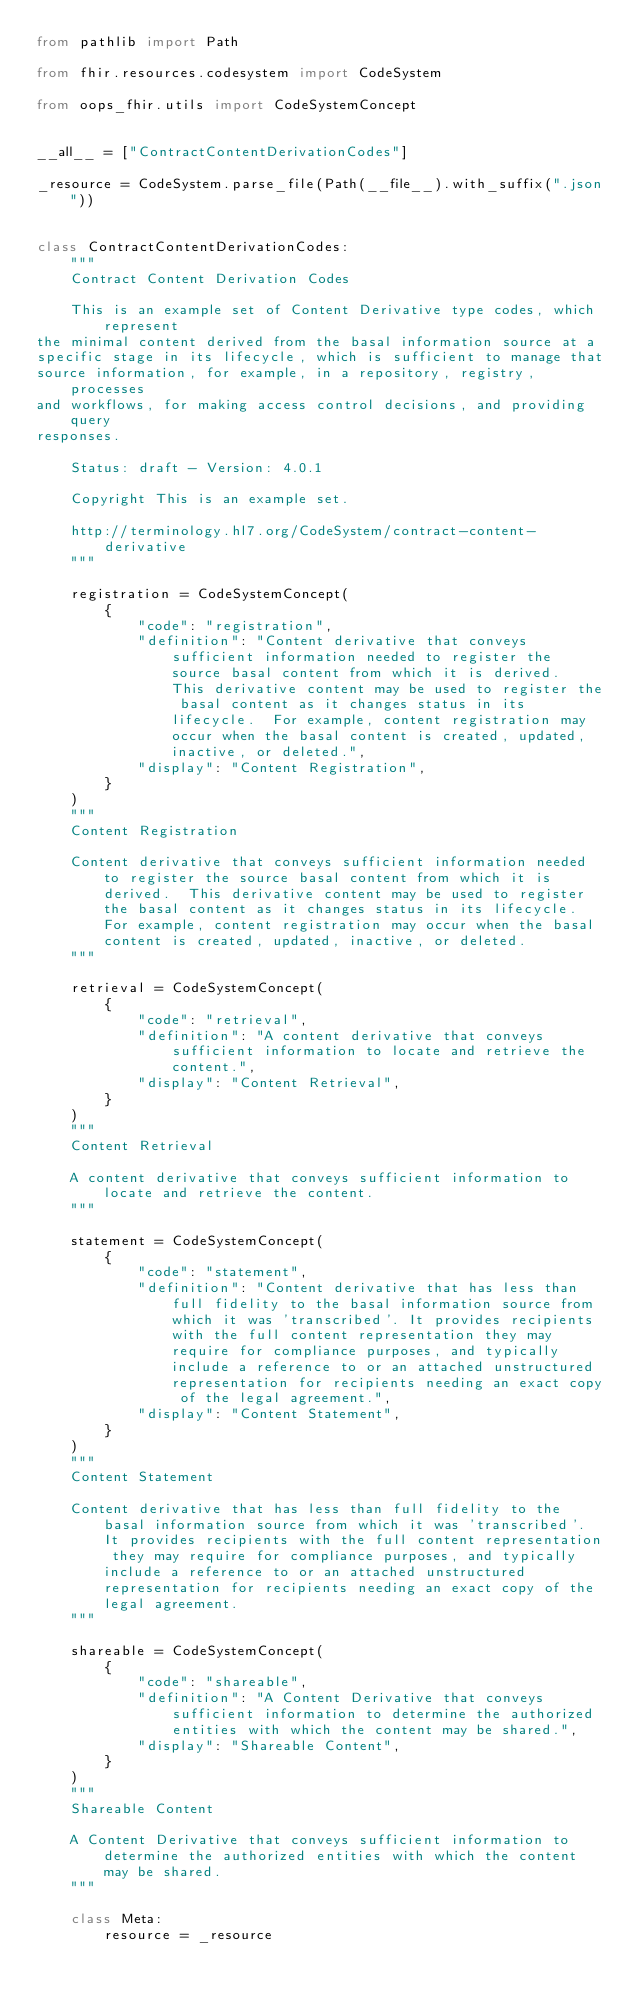Convert code to text. <code><loc_0><loc_0><loc_500><loc_500><_Python_>from pathlib import Path

from fhir.resources.codesystem import CodeSystem

from oops_fhir.utils import CodeSystemConcept


__all__ = ["ContractContentDerivationCodes"]

_resource = CodeSystem.parse_file(Path(__file__).with_suffix(".json"))


class ContractContentDerivationCodes:
    """
    Contract Content Derivation Codes

    This is an example set of Content Derivative type codes, which represent
the minimal content derived from the basal information source at a
specific stage in its lifecycle, which is sufficient to manage that
source information, for example, in a repository, registry, processes
and workflows, for making access control decisions, and providing query
responses.

    Status: draft - Version: 4.0.1

    Copyright This is an example set.

    http://terminology.hl7.org/CodeSystem/contract-content-derivative
    """

    registration = CodeSystemConcept(
        {
            "code": "registration",
            "definition": "Content derivative that conveys sufficient information needed to register the source basal content from which it is derived.  This derivative content may be used to register the basal content as it changes status in its lifecycle.  For example, content registration may occur when the basal content is created, updated, inactive, or deleted.",
            "display": "Content Registration",
        }
    )
    """
    Content Registration

    Content derivative that conveys sufficient information needed to register the source basal content from which it is derived.  This derivative content may be used to register the basal content as it changes status in its lifecycle.  For example, content registration may occur when the basal content is created, updated, inactive, or deleted.
    """

    retrieval = CodeSystemConcept(
        {
            "code": "retrieval",
            "definition": "A content derivative that conveys sufficient information to locate and retrieve the content.",
            "display": "Content Retrieval",
        }
    )
    """
    Content Retrieval

    A content derivative that conveys sufficient information to locate and retrieve the content.
    """

    statement = CodeSystemConcept(
        {
            "code": "statement",
            "definition": "Content derivative that has less than full fidelity to the basal information source from which it was 'transcribed'. It provides recipients with the full content representation they may require for compliance purposes, and typically include a reference to or an attached unstructured representation for recipients needing an exact copy of the legal agreement.",
            "display": "Content Statement",
        }
    )
    """
    Content Statement

    Content derivative that has less than full fidelity to the basal information source from which it was 'transcribed'. It provides recipients with the full content representation they may require for compliance purposes, and typically include a reference to or an attached unstructured representation for recipients needing an exact copy of the legal agreement.
    """

    shareable = CodeSystemConcept(
        {
            "code": "shareable",
            "definition": "A Content Derivative that conveys sufficient information to determine the authorized entities with which the content may be shared.",
            "display": "Shareable Content",
        }
    )
    """
    Shareable Content

    A Content Derivative that conveys sufficient information to determine the authorized entities with which the content may be shared.
    """

    class Meta:
        resource = _resource
</code> 